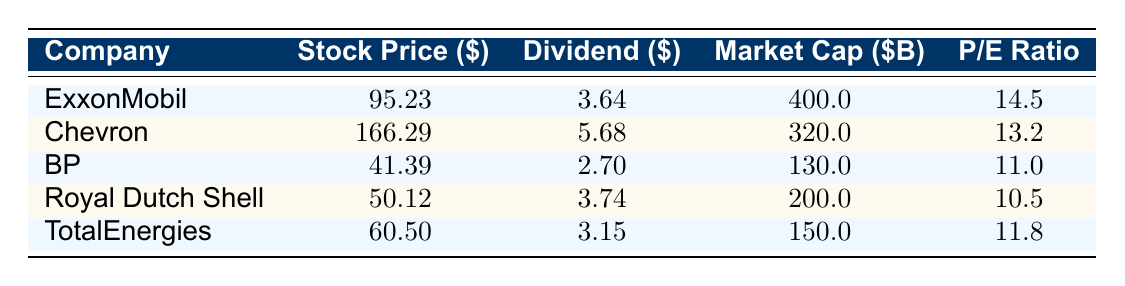What is the stock price of Chevron? The stock price is listed directly in the table under Chevron. Therefore, the stock price of Chevron is 166.29.
Answer: 166.29 Which company has the highest market capitalization? Looking at the market cap column, ExxonMobil is the only company listed with a market cap of 400.0 billion, which is greater than the others.
Answer: ExxonMobil What is the average dividend of all companies listed? To find the average dividend, sum all dividends (3.64 + 5.68 + 2.70 + 3.74 + 3.15 = 19.91) and divide by the total number of companies (5). Thus, the average dividend is 19.91 / 5 = 3.98.
Answer: 3.98 Is the P/E ratio of BP greater than that of TotalEnergies? From the table, BP has a P/E ratio of 11.0 while TotalEnergies has a P/E ratio of 11.8. Since 11.0 is less than 11.8, the answer is no.
Answer: No What is the difference in stock price between ExxonMobil and Royal Dutch Shell? The stock price of ExxonMobil is 95.23 and the stock price of Royal Dutch Shell is 50.12. To find the difference, subtract Royal Dutch Shell's price from ExxonMobil's price: 95.23 - 50.12 = 45.11.
Answer: 45.11 Which company has the lowest dividend among the listed companies? By examining the dividend column, BP has a dividend of 2.70, which is lower than the dividends of the other companies listed in the table.
Answer: BP What is the total market capitalization of all companies combined? To find the total market cap, add the values of all companies' market caps: 400.0 + 320.0 + 130.0 + 200.0 + 150.0 = 1200.0 billion.
Answer: 1200.0 Is the dividend of Chevron higher than the stock price of BP? The dividend of Chevron is 5.68 and the stock price of BP is 41.39. Since 5.68 is less than 41.39, the answer is no.
Answer: No Which company has the highest P/E ratio? The P/E ratios for each company are: ExxonMobil (14.5), Chevron (13.2), BP (11.0), Royal Dutch Shell (10.5), and TotalEnergies (11.8). Among these, ExxonMobil has the highest P/E ratio.
Answer: ExxonMobil 